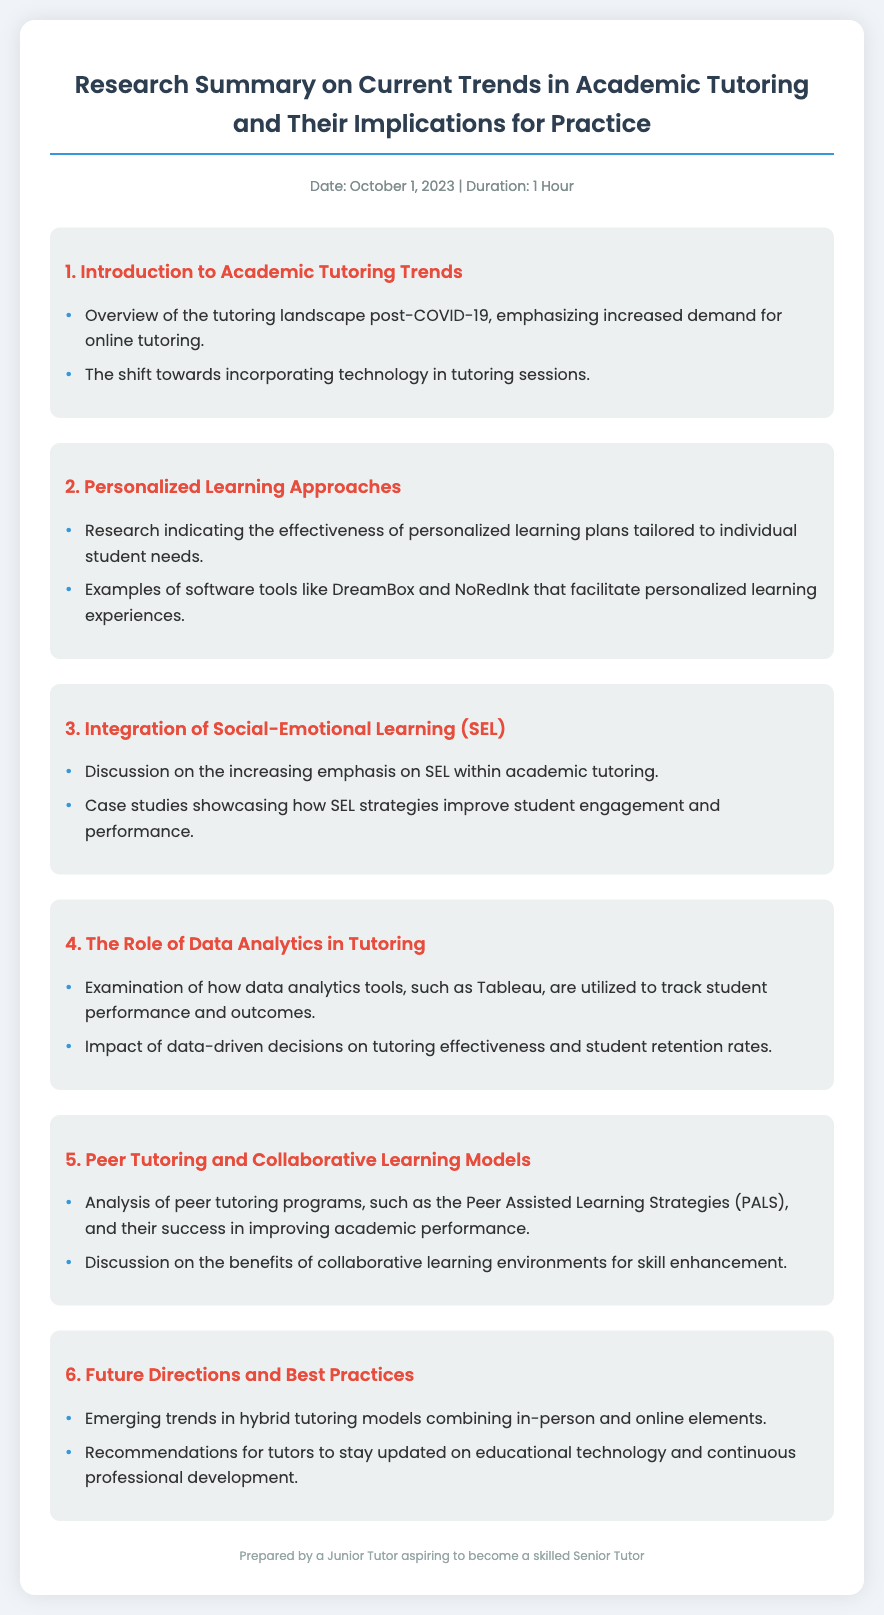What is the date of the research summary? The date is mentioned in the meta-info section of the document, which states October 1, 2023.
Answer: October 1, 2023 What is the duration of the agenda? The duration is specified in the meta-info section, indicating a duration of 1 hour.
Answer: 1 Hour What is a key trend mentioned in the introduction? The introduction highlights the increased demand for online tutoring post-COVID-19 as a significant trend.
Answer: Increased demand for online tutoring Which software tools are examples of personalized learning? The document lists DreamBox and NoRedInk as examples of software that support personalized learning experiences.
Answer: DreamBox and NoRedInk What does SEL stand for? SEL is referenced multiple times regarding its importance in academic tutoring within the document.
Answer: Social-Emotional Learning What is one of the future directions mentioned in the summary? The summary includes emerging trends in hybrid tutoring models as one of the future directions discussed.
Answer: Hybrid tutoring models How does data analytics impact tutoring effectiveness? The document examines the impact of data-driven decisions on tutoring effectiveness and student retention rates.
Answer: Impact of data-driven decisions What tutoring program is analyzed in the peer tutoring section? Peer Assisted Learning Strategies (PALS) is specifically mentioned as an example of a successful peer tutoring program.
Answer: Peer Assisted Learning Strategies (PALS) What is a recommendation for tutors in the best practices section? It is recommended for tutors to stay updated on educational technology as a best practice.
Answer: Stay updated on educational technology 